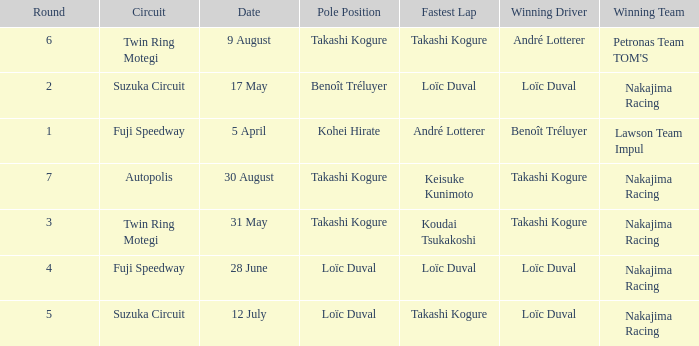Could you parse the entire table as a dict? {'header': ['Round', 'Circuit', 'Date', 'Pole Position', 'Fastest Lap', 'Winning Driver', 'Winning Team'], 'rows': [['6', 'Twin Ring Motegi', '9 August', 'Takashi Kogure', 'Takashi Kogure', 'André Lotterer', "Petronas Team TOM'S"], ['2', 'Suzuka Circuit', '17 May', 'Benoît Tréluyer', 'Loïc Duval', 'Loïc Duval', 'Nakajima Racing'], ['1', 'Fuji Speedway', '5 April', 'Kohei Hirate', 'André Lotterer', 'Benoît Tréluyer', 'Lawson Team Impul'], ['7', 'Autopolis', '30 August', 'Takashi Kogure', 'Keisuke Kunimoto', 'Takashi Kogure', 'Nakajima Racing'], ['3', 'Twin Ring Motegi', '31 May', 'Takashi Kogure', 'Koudai Tsukakoshi', 'Takashi Kogure', 'Nakajima Racing'], ['4', 'Fuji Speedway', '28 June', 'Loïc Duval', 'Loïc Duval', 'Loïc Duval', 'Nakajima Racing'], ['5', 'Suzuka Circuit', '12 July', 'Loïc Duval', 'Takashi Kogure', 'Loïc Duval', 'Nakajima Racing']]} What was the earlier round where Takashi Kogure got the fastest lap? 5.0. 